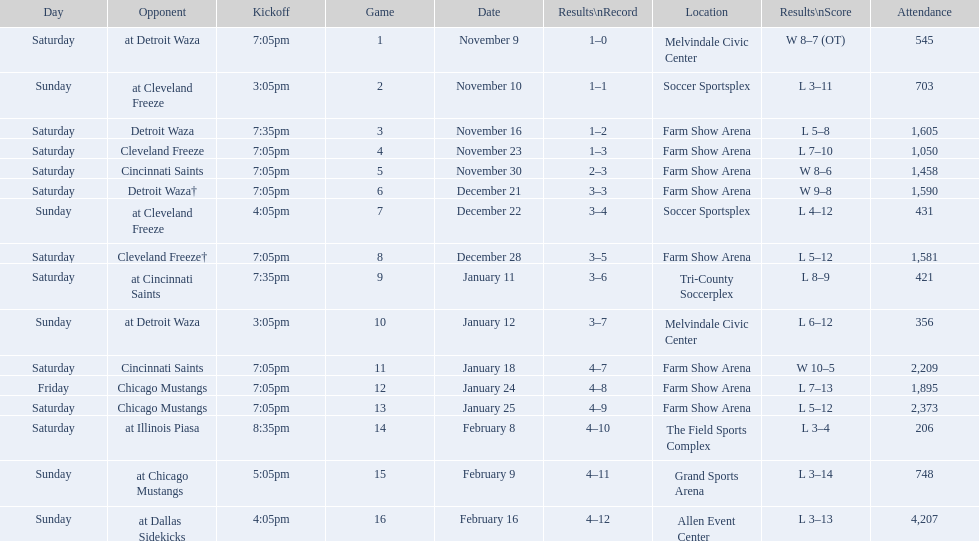Which opponent is listed first in the table? Detroit Waza. 